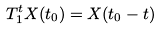<formula> <loc_0><loc_0><loc_500><loc_500>T ^ { t } _ { 1 } X ( t _ { 0 } ) = X ( t _ { 0 } - t )</formula> 